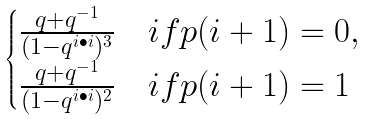<formula> <loc_0><loc_0><loc_500><loc_500>\begin{cases} \frac { q + q ^ { - 1 } } { ( 1 - q ^ { i \bullet i } ) ^ { 3 } } & i f p ( i + 1 ) = 0 , \\ \frac { q + q ^ { - 1 } } { ( 1 - q ^ { i \bullet i } ) ^ { 2 } } & i f p ( i + 1 ) = 1 \end{cases}</formula> 